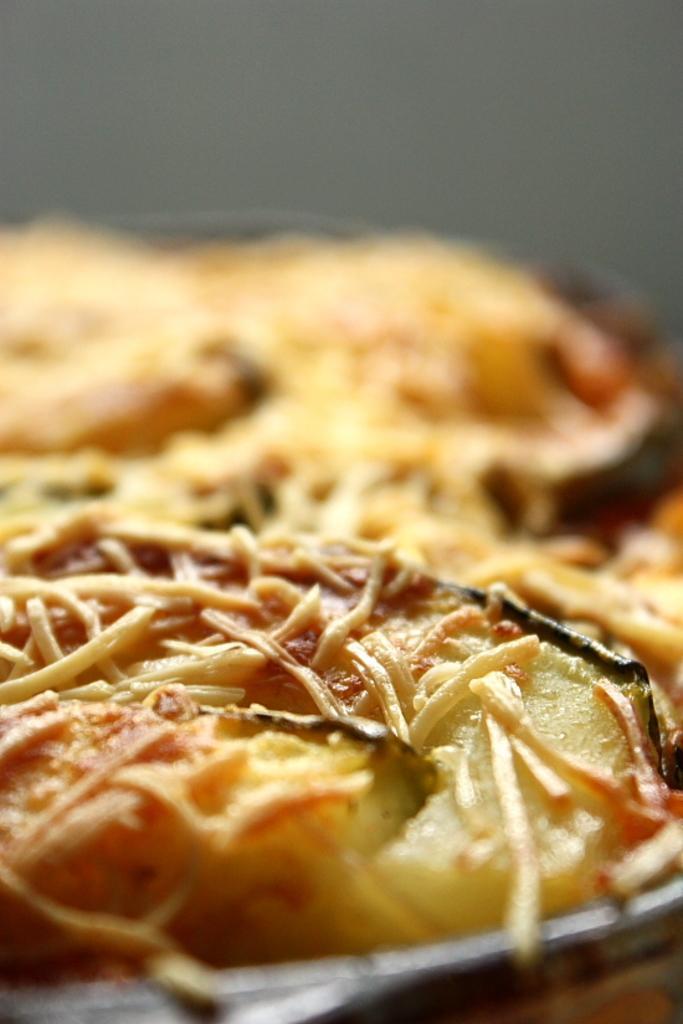Describe this image in one or two sentences. In this picture we can see the pizza on the plate. This plate is kept on the table. At the top there is a wall. 